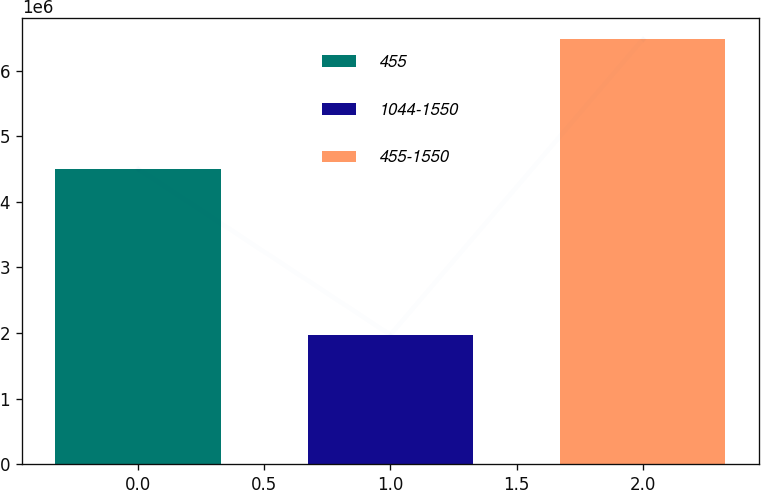<chart> <loc_0><loc_0><loc_500><loc_500><bar_chart><fcel>455<fcel>1044-1550<fcel>455-1550<nl><fcel>4.50562e+06<fcel>1.97282e+06<fcel>6.47844e+06<nl></chart> 